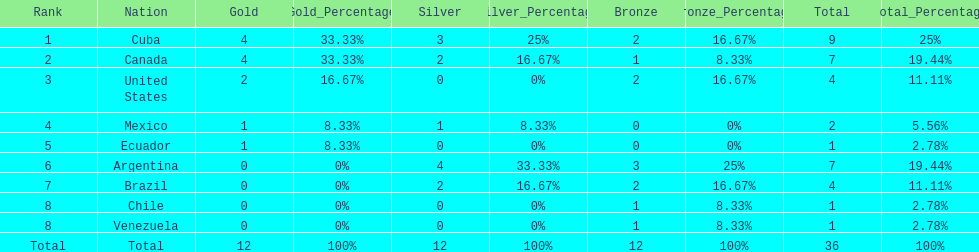Which ranking is mexico? 4. 